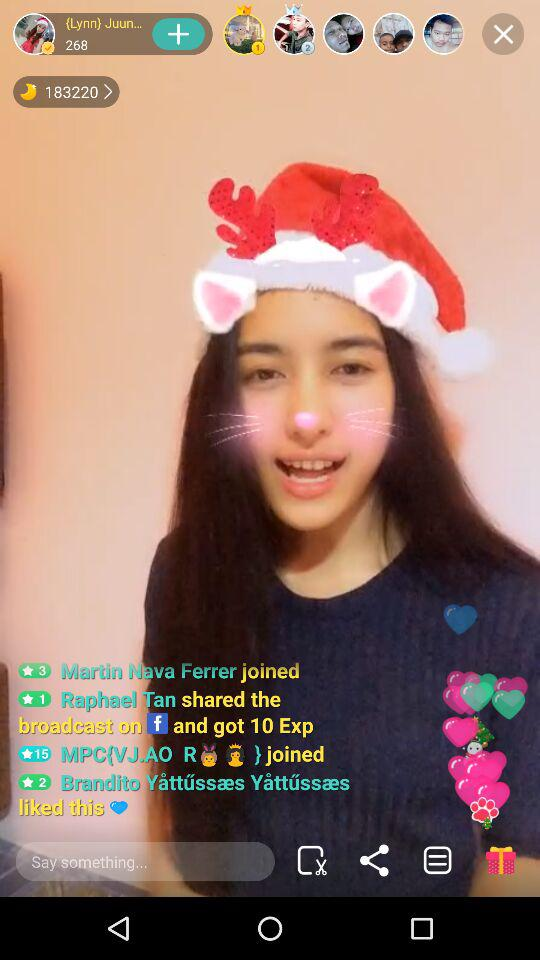What is the user name?
When the provided information is insufficient, respond with <no answer>. <no answer> 